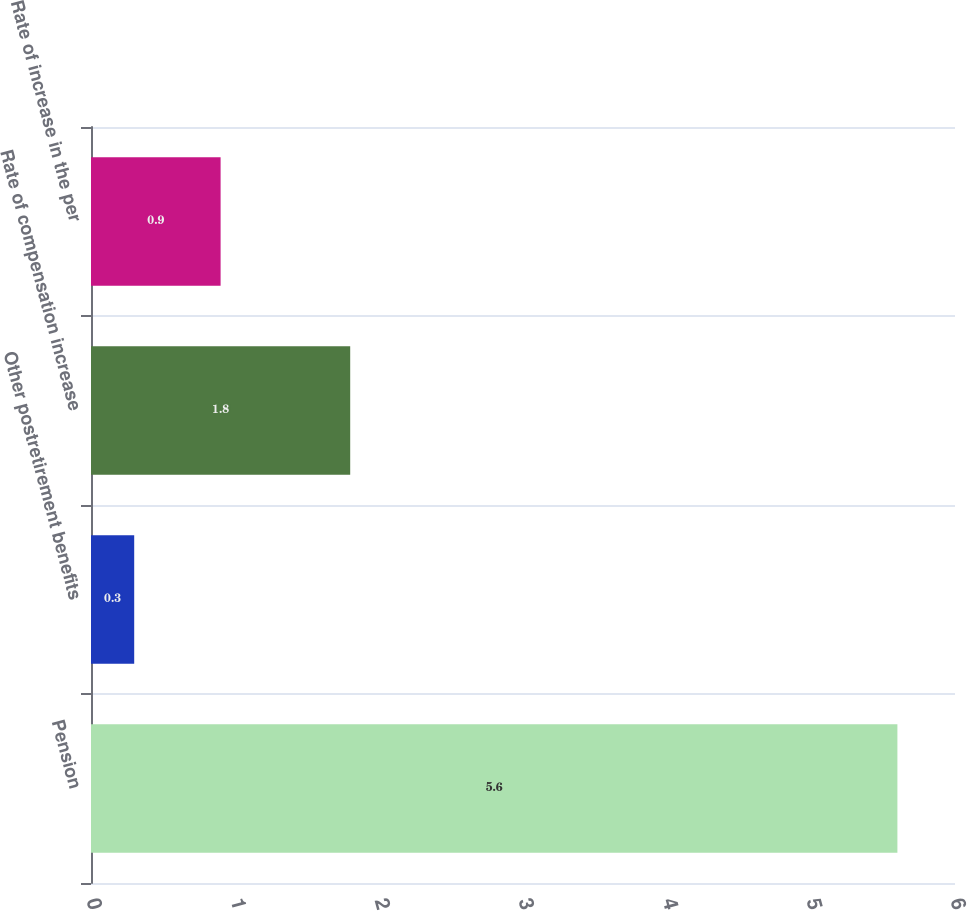Convert chart. <chart><loc_0><loc_0><loc_500><loc_500><bar_chart><fcel>Pension<fcel>Other postretirement benefits<fcel>Rate of compensation increase<fcel>Rate of increase in the per<nl><fcel>5.6<fcel>0.3<fcel>1.8<fcel>0.9<nl></chart> 